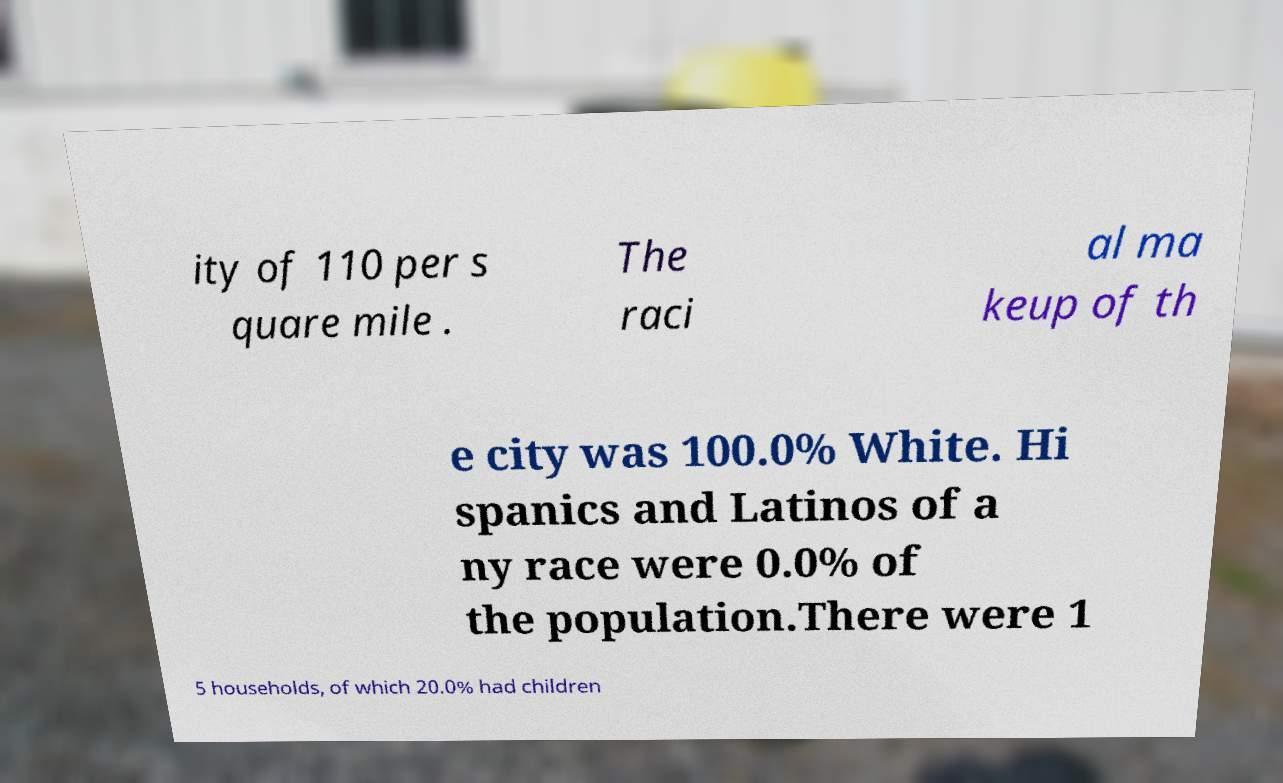I need the written content from this picture converted into text. Can you do that? ity of 110 per s quare mile . The raci al ma keup of th e city was 100.0% White. Hi spanics and Latinos of a ny race were 0.0% of the population.There were 1 5 households, of which 20.0% had children 